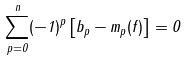Convert formula to latex. <formula><loc_0><loc_0><loc_500><loc_500>\sum _ { p = 0 } ^ { n } ( - 1 ) ^ { p } \left [ b _ { p } - m _ { p } ( f ) \right ] = 0</formula> 